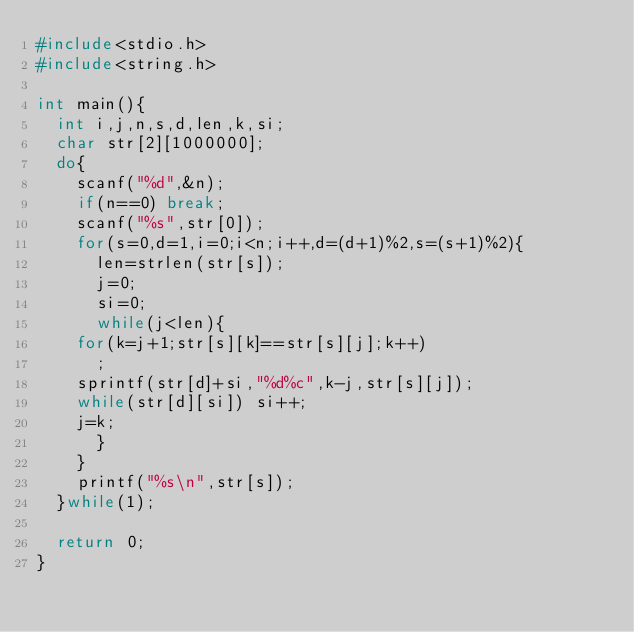Convert code to text. <code><loc_0><loc_0><loc_500><loc_500><_C_>#include<stdio.h>
#include<string.h>

int main(){
  int i,j,n,s,d,len,k,si;
  char str[2][1000000];
  do{
    scanf("%d",&n);
    if(n==0) break;
    scanf("%s",str[0]);
    for(s=0,d=1,i=0;i<n;i++,d=(d+1)%2,s=(s+1)%2){
      len=strlen(str[s]);
      j=0;
      si=0;
      while(j<len){
	for(k=j+1;str[s][k]==str[s][j];k++)
	  ;
	sprintf(str[d]+si,"%d%c",k-j,str[s][j]);
	while(str[d][si]) si++;
	j=k;
      }	      
    }
    printf("%s\n",str[s]);
  }while(1);

  return 0;
}</code> 